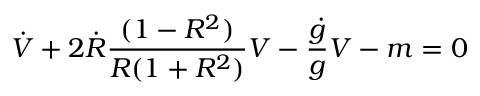Convert formula to latex. <formula><loc_0><loc_0><loc_500><loc_500>\dot { V } + 2 \dot { R } { \frac { ( 1 - R ^ { 2 } ) } { R ( 1 + R ^ { 2 } ) } } V - { \frac { \dot { g } } { g } } V - m = 0</formula> 